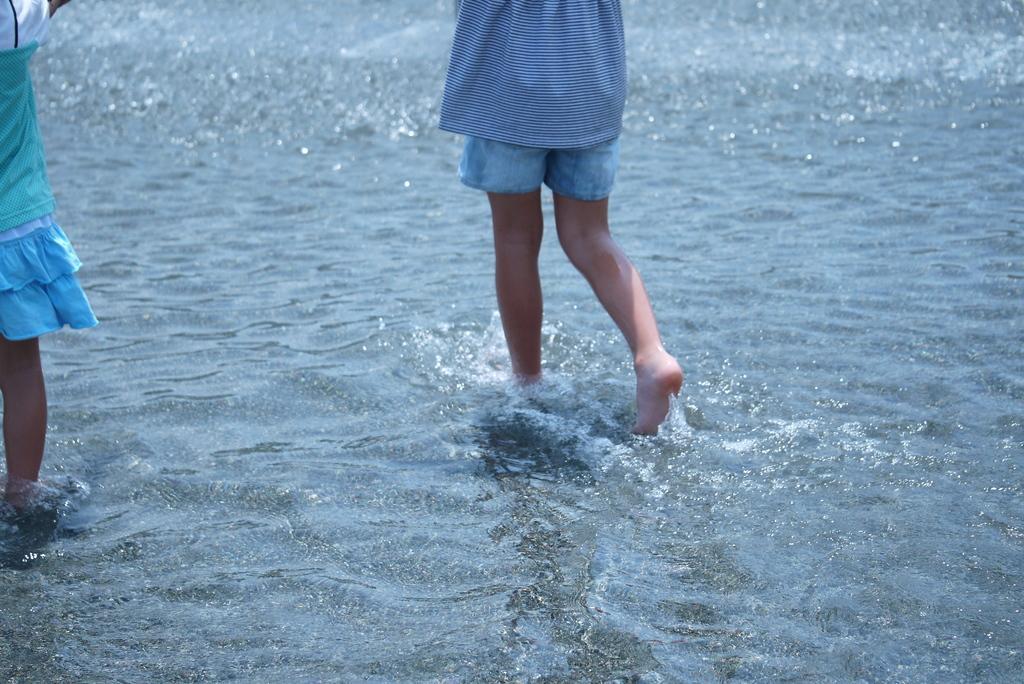Please provide a concise description of this image. On the left side, there is a child partially in the water. On the right side, there is another child, walking in the water. 